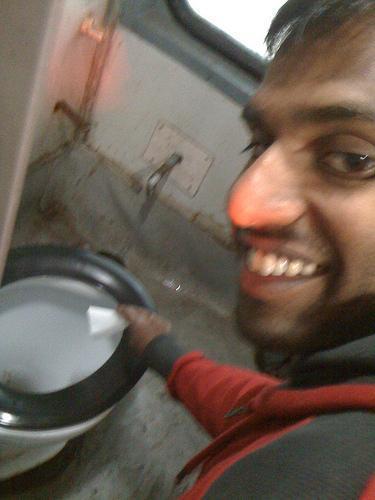How many windows are shown?
Give a very brief answer. 1. How many people are shown?
Give a very brief answer. 1. How many toilets are seen?
Give a very brief answer. 1. 